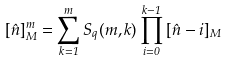Convert formula to latex. <formula><loc_0><loc_0><loc_500><loc_500>[ \hat { n } ] _ { M } ^ { m } = \sum _ { k = 1 } ^ { m } S _ { q } ( m , k ) \prod _ { i = 0 } ^ { k - 1 } \, [ \hat { n } - i ] _ { M }</formula> 